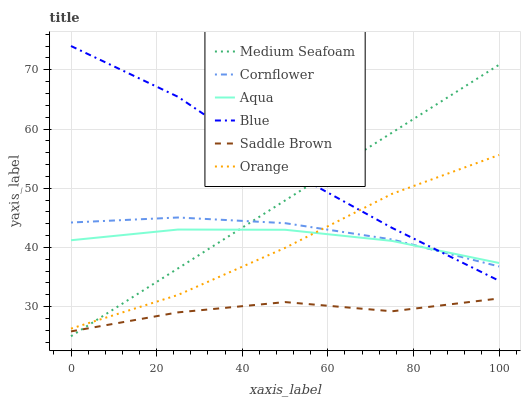Does Saddle Brown have the minimum area under the curve?
Answer yes or no. Yes. Does Blue have the maximum area under the curve?
Answer yes or no. Yes. Does Cornflower have the minimum area under the curve?
Answer yes or no. No. Does Cornflower have the maximum area under the curve?
Answer yes or no. No. Is Medium Seafoam the smoothest?
Answer yes or no. Yes. Is Saddle Brown the roughest?
Answer yes or no. Yes. Is Cornflower the smoothest?
Answer yes or no. No. Is Cornflower the roughest?
Answer yes or no. No. Does Cornflower have the lowest value?
Answer yes or no. No. Does Blue have the highest value?
Answer yes or no. Yes. Does Cornflower have the highest value?
Answer yes or no. No. Is Saddle Brown less than Cornflower?
Answer yes or no. Yes. Is Orange greater than Saddle Brown?
Answer yes or no. Yes. Does Aqua intersect Cornflower?
Answer yes or no. Yes. Is Aqua less than Cornflower?
Answer yes or no. No. Is Aqua greater than Cornflower?
Answer yes or no. No. Does Saddle Brown intersect Cornflower?
Answer yes or no. No. 